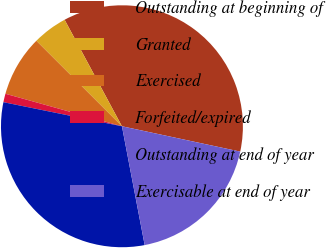<chart> <loc_0><loc_0><loc_500><loc_500><pie_chart><fcel>Outstanding at beginning of<fcel>Granted<fcel>Exercised<fcel>Forfeited/expired<fcel>Outstanding at end of year<fcel>Exercisable at end of year<nl><fcel>36.22%<fcel>4.65%<fcel>8.16%<fcel>1.14%<fcel>31.2%<fcel>18.63%<nl></chart> 